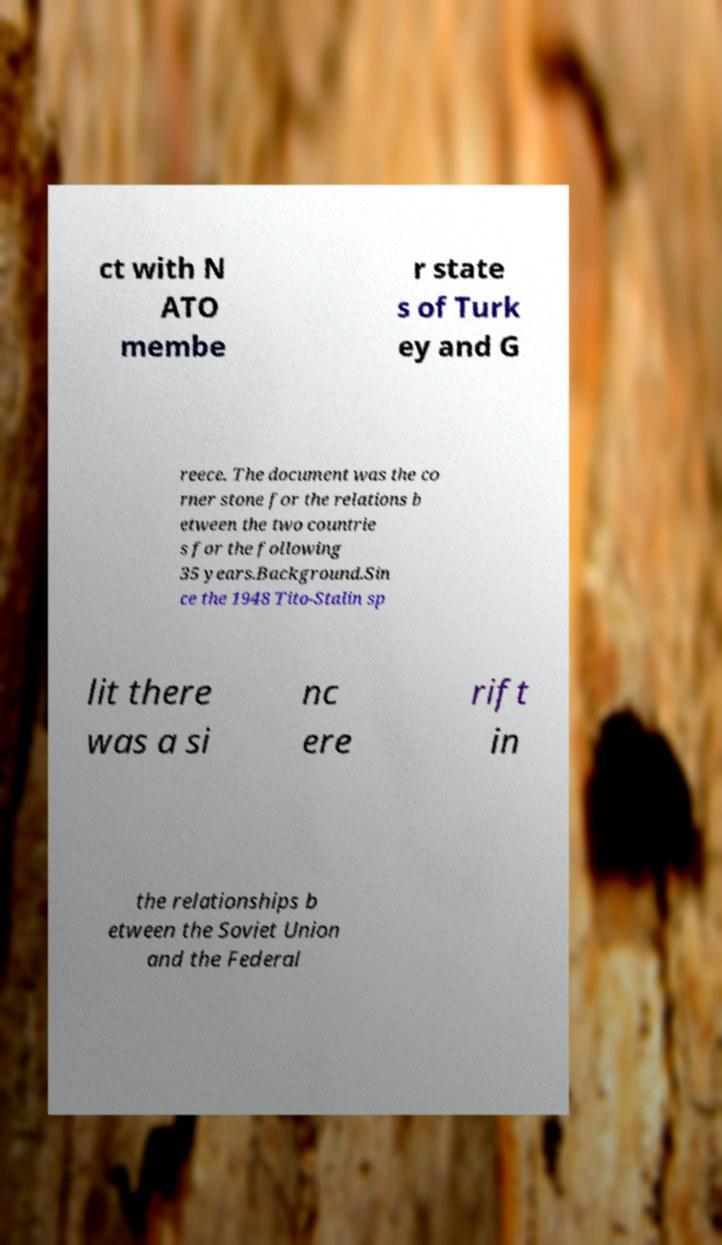What messages or text are displayed in this image? I need them in a readable, typed format. ct with N ATO membe r state s of Turk ey and G reece. The document was the co rner stone for the relations b etween the two countrie s for the following 35 years.Background.Sin ce the 1948 Tito-Stalin sp lit there was a si nc ere rift in the relationships b etween the Soviet Union and the Federal 